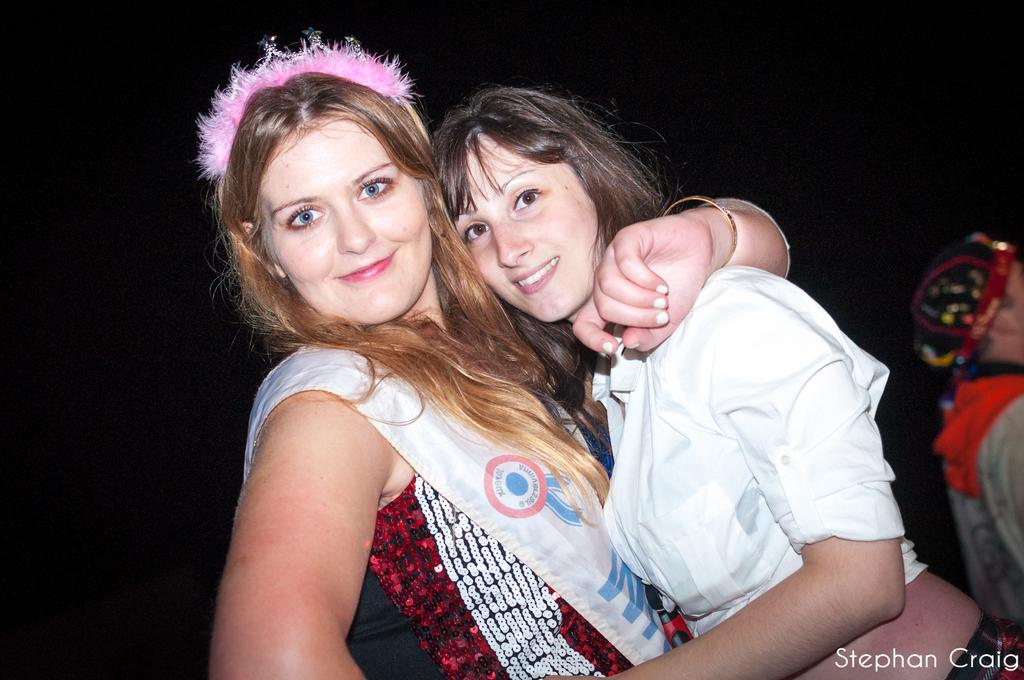How many people are in the image? There are people in the image, but the exact number is not specified. What is unique about the appearance of one person in the image? One person is wearing a band on their head and a sash. What can be found at the bottom of the image? There is text at the bottom of the image. How would you describe the lighting or color of the background in the image? The background of the image is dark. What type of substance is being wasted in the image? There is no indication of any substance being wasted in the image. What causes the band to burst in the image? There is no band that bursts in the image; the person is wearing a band on their head, but it is not depicted as bursting. 